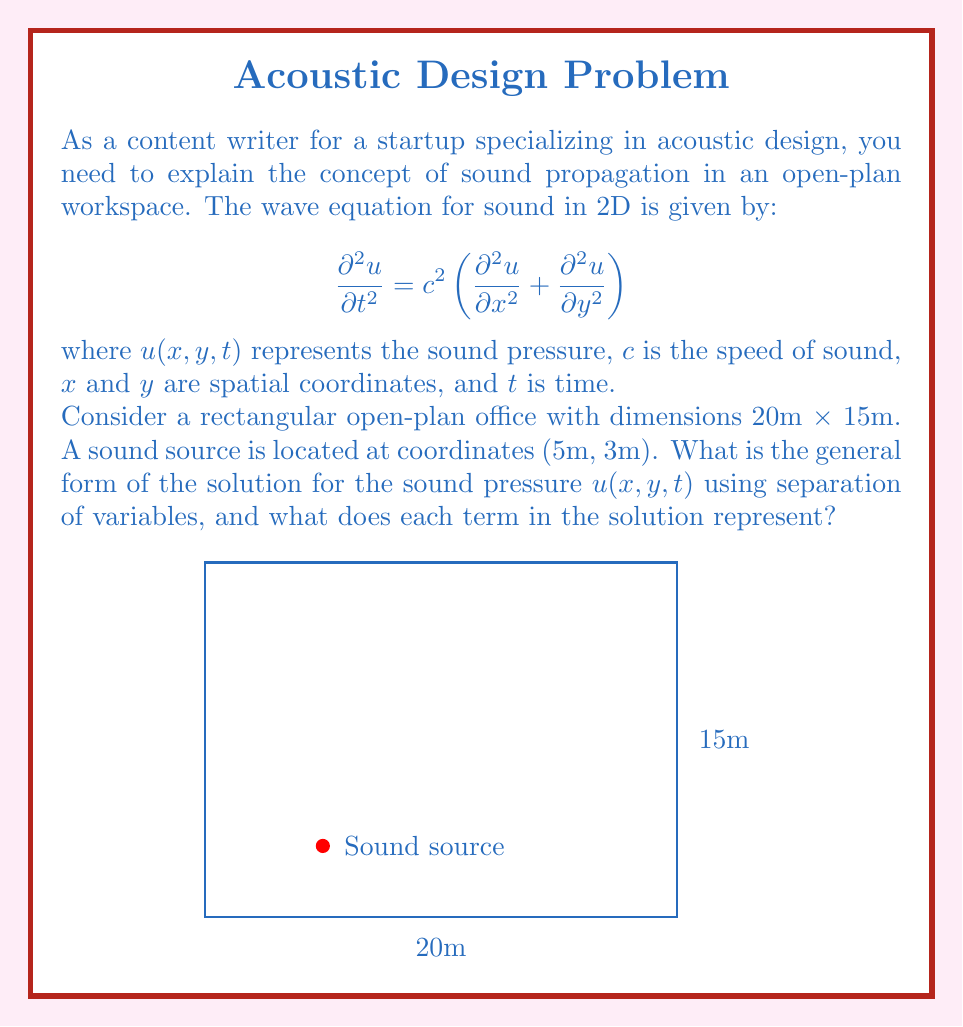Teach me how to tackle this problem. To solve this problem, we'll use the method of separation of variables:

1) Assume the solution has the form: $u(x,y,t) = X(x)Y(y)T(t)$

2) Substitute this into the wave equation:

   $$ XYT'' = c^2(X''YT + XY''T) $$

3) Divide both sides by $XYT$:

   $$ \frac{T''}{T} = c^2\left(\frac{X''}{X} + \frac{Y''}{Y}\right) $$

4) Since the left side depends only on $t$ and the right side only on $x$ and $y$, both must equal a constant. Let's call this constant $-\omega^2$:

   $$ \frac{T''}{T} = -\omega^2 $$
   $$ c^2\left(\frac{X''}{X} + \frac{Y''}{Y}\right) = -\omega^2 $$

5) From the first equation:
   $$ T(t) = A\cos(\omega t) + B\sin(\omega t) $$

6) For the spatial part, let $\frac{X''}{X} = -k_x^2$ and $\frac{Y''}{Y} = -k_y^2$. Then:

   $$ X(x) = C\cos(k_x x) + D\sin(k_x x) $$
   $$ Y(y) = E\cos(k_y y) + F\sin(k_y y) $$

7) The wavenumbers $k_x$ and $k_y$ are related to $\omega$ by:

   $$ \omega^2 = c^2(k_x^2 + k_y^2) $$

8) The general solution is the product of these functions:

   $$ u(x,y,t) = [C\cos(k_x x) + D\sin(k_x x)][E\cos(k_y y) + F\sin(k_y y)][A\cos(\omega t) + B\sin(\omega t)] $$

Each term in this solution represents:
- $X(x)$ and $Y(y)$: Spatial distribution of sound pressure in $x$ and $y$ directions
- $T(t)$: Time-dependent oscillation of sound pressure
- $k_x$ and $k_y$: Wavenumbers in $x$ and $y$ directions
- $\omega$: Angular frequency of the sound wave
- $A$, $B$, $C$, $D$, $E$, $F$: Constants determined by initial and boundary conditions
Answer: $u(x,y,t) = [C\cos(k_x x) + D\sin(k_x x)][E\cos(k_y y) + F\sin(k_y y)][A\cos(\omega t) + B\sin(\omega t)]$ 